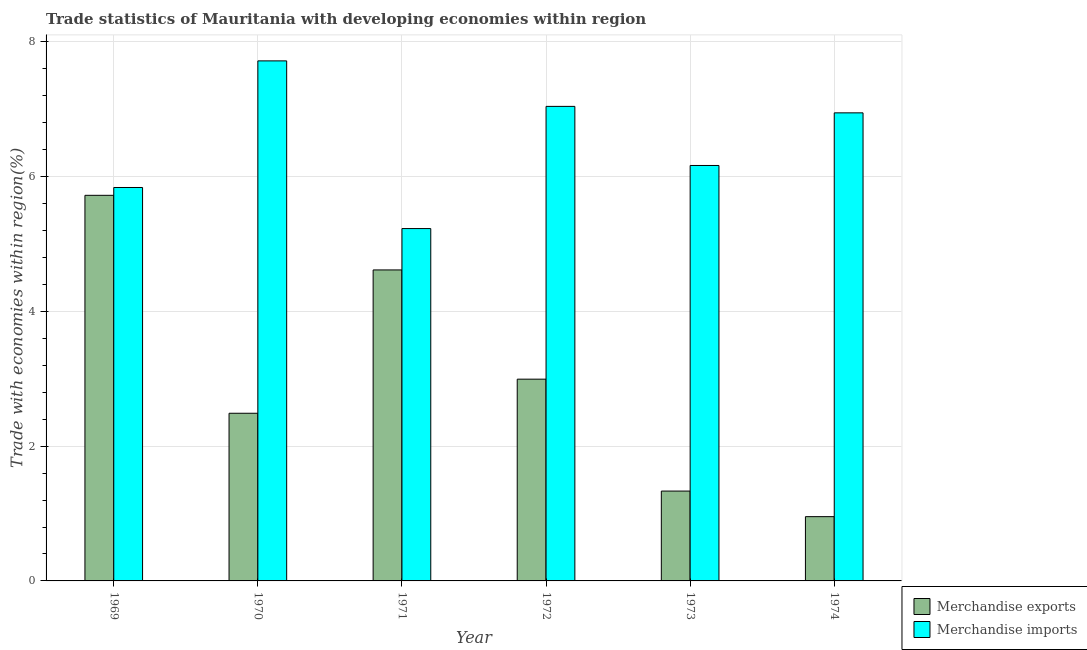How many different coloured bars are there?
Offer a terse response. 2. How many groups of bars are there?
Make the answer very short. 6. Are the number of bars per tick equal to the number of legend labels?
Your response must be concise. Yes. Are the number of bars on each tick of the X-axis equal?
Ensure brevity in your answer.  Yes. What is the label of the 1st group of bars from the left?
Your answer should be very brief. 1969. In how many cases, is the number of bars for a given year not equal to the number of legend labels?
Offer a terse response. 0. What is the merchandise exports in 1974?
Provide a succinct answer. 0.95. Across all years, what is the maximum merchandise exports?
Provide a succinct answer. 5.72. Across all years, what is the minimum merchandise imports?
Your answer should be very brief. 5.23. In which year was the merchandise exports maximum?
Your response must be concise. 1969. In which year was the merchandise exports minimum?
Make the answer very short. 1974. What is the total merchandise imports in the graph?
Make the answer very short. 38.93. What is the difference between the merchandise exports in 1971 and that in 1974?
Your answer should be compact. 3.66. What is the difference between the merchandise exports in 1969 and the merchandise imports in 1972?
Your response must be concise. 2.73. What is the average merchandise imports per year?
Offer a terse response. 6.49. In the year 1970, what is the difference between the merchandise exports and merchandise imports?
Your response must be concise. 0. What is the ratio of the merchandise exports in 1972 to that in 1974?
Make the answer very short. 3.14. Is the difference between the merchandise exports in 1969 and 1974 greater than the difference between the merchandise imports in 1969 and 1974?
Ensure brevity in your answer.  No. What is the difference between the highest and the second highest merchandise imports?
Keep it short and to the point. 0.68. What is the difference between the highest and the lowest merchandise imports?
Your response must be concise. 2.49. What does the 1st bar from the left in 1974 represents?
Provide a short and direct response. Merchandise exports. What does the 2nd bar from the right in 1973 represents?
Make the answer very short. Merchandise exports. How many bars are there?
Make the answer very short. 12. How many years are there in the graph?
Provide a short and direct response. 6. Are the values on the major ticks of Y-axis written in scientific E-notation?
Ensure brevity in your answer.  No. Does the graph contain any zero values?
Give a very brief answer. No. Does the graph contain grids?
Your answer should be very brief. Yes. Where does the legend appear in the graph?
Provide a short and direct response. Bottom right. How many legend labels are there?
Provide a short and direct response. 2. What is the title of the graph?
Provide a succinct answer. Trade statistics of Mauritania with developing economies within region. What is the label or title of the X-axis?
Keep it short and to the point. Year. What is the label or title of the Y-axis?
Give a very brief answer. Trade with economies within region(%). What is the Trade with economies within region(%) in Merchandise exports in 1969?
Offer a very short reply. 5.72. What is the Trade with economies within region(%) in Merchandise imports in 1969?
Offer a terse response. 5.84. What is the Trade with economies within region(%) of Merchandise exports in 1970?
Keep it short and to the point. 2.49. What is the Trade with economies within region(%) of Merchandise imports in 1970?
Provide a succinct answer. 7.72. What is the Trade with economies within region(%) in Merchandise exports in 1971?
Make the answer very short. 4.61. What is the Trade with economies within region(%) in Merchandise imports in 1971?
Give a very brief answer. 5.23. What is the Trade with economies within region(%) in Merchandise exports in 1972?
Give a very brief answer. 2.99. What is the Trade with economies within region(%) of Merchandise imports in 1972?
Your answer should be very brief. 7.04. What is the Trade with economies within region(%) of Merchandise exports in 1973?
Offer a terse response. 1.33. What is the Trade with economies within region(%) in Merchandise imports in 1973?
Offer a terse response. 6.16. What is the Trade with economies within region(%) in Merchandise exports in 1974?
Your answer should be very brief. 0.95. What is the Trade with economies within region(%) of Merchandise imports in 1974?
Give a very brief answer. 6.94. Across all years, what is the maximum Trade with economies within region(%) in Merchandise exports?
Make the answer very short. 5.72. Across all years, what is the maximum Trade with economies within region(%) in Merchandise imports?
Ensure brevity in your answer.  7.72. Across all years, what is the minimum Trade with economies within region(%) in Merchandise exports?
Make the answer very short. 0.95. Across all years, what is the minimum Trade with economies within region(%) in Merchandise imports?
Provide a succinct answer. 5.23. What is the total Trade with economies within region(%) of Merchandise exports in the graph?
Provide a short and direct response. 18.1. What is the total Trade with economies within region(%) in Merchandise imports in the graph?
Your answer should be compact. 38.93. What is the difference between the Trade with economies within region(%) of Merchandise exports in 1969 and that in 1970?
Give a very brief answer. 3.23. What is the difference between the Trade with economies within region(%) of Merchandise imports in 1969 and that in 1970?
Offer a very short reply. -1.88. What is the difference between the Trade with economies within region(%) in Merchandise exports in 1969 and that in 1971?
Your response must be concise. 1.11. What is the difference between the Trade with economies within region(%) of Merchandise imports in 1969 and that in 1971?
Your answer should be very brief. 0.61. What is the difference between the Trade with economies within region(%) of Merchandise exports in 1969 and that in 1972?
Your response must be concise. 2.73. What is the difference between the Trade with economies within region(%) in Merchandise imports in 1969 and that in 1972?
Provide a short and direct response. -1.2. What is the difference between the Trade with economies within region(%) of Merchandise exports in 1969 and that in 1973?
Your answer should be compact. 4.39. What is the difference between the Trade with economies within region(%) in Merchandise imports in 1969 and that in 1973?
Your answer should be compact. -0.33. What is the difference between the Trade with economies within region(%) in Merchandise exports in 1969 and that in 1974?
Give a very brief answer. 4.77. What is the difference between the Trade with economies within region(%) of Merchandise imports in 1969 and that in 1974?
Ensure brevity in your answer.  -1.11. What is the difference between the Trade with economies within region(%) in Merchandise exports in 1970 and that in 1971?
Keep it short and to the point. -2.13. What is the difference between the Trade with economies within region(%) in Merchandise imports in 1970 and that in 1971?
Your response must be concise. 2.49. What is the difference between the Trade with economies within region(%) of Merchandise exports in 1970 and that in 1972?
Your answer should be compact. -0.51. What is the difference between the Trade with economies within region(%) in Merchandise imports in 1970 and that in 1972?
Your answer should be compact. 0.68. What is the difference between the Trade with economies within region(%) in Merchandise exports in 1970 and that in 1973?
Your answer should be very brief. 1.15. What is the difference between the Trade with economies within region(%) in Merchandise imports in 1970 and that in 1973?
Keep it short and to the point. 1.55. What is the difference between the Trade with economies within region(%) in Merchandise exports in 1970 and that in 1974?
Provide a short and direct response. 1.53. What is the difference between the Trade with economies within region(%) of Merchandise imports in 1970 and that in 1974?
Your response must be concise. 0.77. What is the difference between the Trade with economies within region(%) in Merchandise exports in 1971 and that in 1972?
Your response must be concise. 1.62. What is the difference between the Trade with economies within region(%) in Merchandise imports in 1971 and that in 1972?
Ensure brevity in your answer.  -1.81. What is the difference between the Trade with economies within region(%) of Merchandise exports in 1971 and that in 1973?
Your response must be concise. 3.28. What is the difference between the Trade with economies within region(%) of Merchandise imports in 1971 and that in 1973?
Your response must be concise. -0.94. What is the difference between the Trade with economies within region(%) in Merchandise exports in 1971 and that in 1974?
Keep it short and to the point. 3.66. What is the difference between the Trade with economies within region(%) of Merchandise imports in 1971 and that in 1974?
Offer a terse response. -1.72. What is the difference between the Trade with economies within region(%) in Merchandise exports in 1972 and that in 1973?
Make the answer very short. 1.66. What is the difference between the Trade with economies within region(%) in Merchandise imports in 1972 and that in 1973?
Provide a short and direct response. 0.88. What is the difference between the Trade with economies within region(%) in Merchandise exports in 1972 and that in 1974?
Give a very brief answer. 2.04. What is the difference between the Trade with economies within region(%) in Merchandise imports in 1972 and that in 1974?
Ensure brevity in your answer.  0.1. What is the difference between the Trade with economies within region(%) of Merchandise exports in 1973 and that in 1974?
Make the answer very short. 0.38. What is the difference between the Trade with economies within region(%) in Merchandise imports in 1973 and that in 1974?
Your answer should be very brief. -0.78. What is the difference between the Trade with economies within region(%) in Merchandise exports in 1969 and the Trade with economies within region(%) in Merchandise imports in 1970?
Offer a terse response. -1.99. What is the difference between the Trade with economies within region(%) of Merchandise exports in 1969 and the Trade with economies within region(%) of Merchandise imports in 1971?
Your answer should be compact. 0.49. What is the difference between the Trade with economies within region(%) of Merchandise exports in 1969 and the Trade with economies within region(%) of Merchandise imports in 1972?
Ensure brevity in your answer.  -1.32. What is the difference between the Trade with economies within region(%) in Merchandise exports in 1969 and the Trade with economies within region(%) in Merchandise imports in 1973?
Make the answer very short. -0.44. What is the difference between the Trade with economies within region(%) in Merchandise exports in 1969 and the Trade with economies within region(%) in Merchandise imports in 1974?
Your answer should be compact. -1.22. What is the difference between the Trade with economies within region(%) of Merchandise exports in 1970 and the Trade with economies within region(%) of Merchandise imports in 1971?
Your answer should be compact. -2.74. What is the difference between the Trade with economies within region(%) in Merchandise exports in 1970 and the Trade with economies within region(%) in Merchandise imports in 1972?
Make the answer very short. -4.55. What is the difference between the Trade with economies within region(%) of Merchandise exports in 1970 and the Trade with economies within region(%) of Merchandise imports in 1973?
Your response must be concise. -3.68. What is the difference between the Trade with economies within region(%) of Merchandise exports in 1970 and the Trade with economies within region(%) of Merchandise imports in 1974?
Your answer should be very brief. -4.46. What is the difference between the Trade with economies within region(%) of Merchandise exports in 1971 and the Trade with economies within region(%) of Merchandise imports in 1972?
Provide a short and direct response. -2.43. What is the difference between the Trade with economies within region(%) of Merchandise exports in 1971 and the Trade with economies within region(%) of Merchandise imports in 1973?
Provide a succinct answer. -1.55. What is the difference between the Trade with economies within region(%) of Merchandise exports in 1971 and the Trade with economies within region(%) of Merchandise imports in 1974?
Provide a short and direct response. -2.33. What is the difference between the Trade with economies within region(%) in Merchandise exports in 1972 and the Trade with economies within region(%) in Merchandise imports in 1973?
Give a very brief answer. -3.17. What is the difference between the Trade with economies within region(%) of Merchandise exports in 1972 and the Trade with economies within region(%) of Merchandise imports in 1974?
Make the answer very short. -3.95. What is the difference between the Trade with economies within region(%) of Merchandise exports in 1973 and the Trade with economies within region(%) of Merchandise imports in 1974?
Give a very brief answer. -5.61. What is the average Trade with economies within region(%) in Merchandise exports per year?
Ensure brevity in your answer.  3.02. What is the average Trade with economies within region(%) of Merchandise imports per year?
Your response must be concise. 6.49. In the year 1969, what is the difference between the Trade with economies within region(%) of Merchandise exports and Trade with economies within region(%) of Merchandise imports?
Give a very brief answer. -0.12. In the year 1970, what is the difference between the Trade with economies within region(%) of Merchandise exports and Trade with economies within region(%) of Merchandise imports?
Provide a succinct answer. -5.23. In the year 1971, what is the difference between the Trade with economies within region(%) in Merchandise exports and Trade with economies within region(%) in Merchandise imports?
Give a very brief answer. -0.61. In the year 1972, what is the difference between the Trade with economies within region(%) in Merchandise exports and Trade with economies within region(%) in Merchandise imports?
Offer a very short reply. -4.05. In the year 1973, what is the difference between the Trade with economies within region(%) of Merchandise exports and Trade with economies within region(%) of Merchandise imports?
Offer a terse response. -4.83. In the year 1974, what is the difference between the Trade with economies within region(%) of Merchandise exports and Trade with economies within region(%) of Merchandise imports?
Your answer should be compact. -5.99. What is the ratio of the Trade with economies within region(%) of Merchandise exports in 1969 to that in 1970?
Your response must be concise. 2.3. What is the ratio of the Trade with economies within region(%) in Merchandise imports in 1969 to that in 1970?
Keep it short and to the point. 0.76. What is the ratio of the Trade with economies within region(%) in Merchandise exports in 1969 to that in 1971?
Give a very brief answer. 1.24. What is the ratio of the Trade with economies within region(%) of Merchandise imports in 1969 to that in 1971?
Make the answer very short. 1.12. What is the ratio of the Trade with economies within region(%) of Merchandise exports in 1969 to that in 1972?
Provide a short and direct response. 1.91. What is the ratio of the Trade with economies within region(%) in Merchandise imports in 1969 to that in 1972?
Your answer should be compact. 0.83. What is the ratio of the Trade with economies within region(%) in Merchandise exports in 1969 to that in 1973?
Your answer should be very brief. 4.29. What is the ratio of the Trade with economies within region(%) in Merchandise imports in 1969 to that in 1973?
Offer a terse response. 0.95. What is the ratio of the Trade with economies within region(%) of Merchandise exports in 1969 to that in 1974?
Offer a terse response. 6. What is the ratio of the Trade with economies within region(%) in Merchandise imports in 1969 to that in 1974?
Your answer should be very brief. 0.84. What is the ratio of the Trade with economies within region(%) of Merchandise exports in 1970 to that in 1971?
Give a very brief answer. 0.54. What is the ratio of the Trade with economies within region(%) in Merchandise imports in 1970 to that in 1971?
Ensure brevity in your answer.  1.48. What is the ratio of the Trade with economies within region(%) of Merchandise exports in 1970 to that in 1972?
Give a very brief answer. 0.83. What is the ratio of the Trade with economies within region(%) in Merchandise imports in 1970 to that in 1972?
Offer a terse response. 1.1. What is the ratio of the Trade with economies within region(%) of Merchandise exports in 1970 to that in 1973?
Provide a succinct answer. 1.87. What is the ratio of the Trade with economies within region(%) of Merchandise imports in 1970 to that in 1973?
Offer a terse response. 1.25. What is the ratio of the Trade with economies within region(%) of Merchandise exports in 1970 to that in 1974?
Ensure brevity in your answer.  2.61. What is the ratio of the Trade with economies within region(%) of Merchandise imports in 1970 to that in 1974?
Ensure brevity in your answer.  1.11. What is the ratio of the Trade with economies within region(%) of Merchandise exports in 1971 to that in 1972?
Provide a short and direct response. 1.54. What is the ratio of the Trade with economies within region(%) of Merchandise imports in 1971 to that in 1972?
Your answer should be compact. 0.74. What is the ratio of the Trade with economies within region(%) in Merchandise exports in 1971 to that in 1973?
Your response must be concise. 3.46. What is the ratio of the Trade with economies within region(%) in Merchandise imports in 1971 to that in 1973?
Keep it short and to the point. 0.85. What is the ratio of the Trade with economies within region(%) in Merchandise exports in 1971 to that in 1974?
Give a very brief answer. 4.84. What is the ratio of the Trade with economies within region(%) in Merchandise imports in 1971 to that in 1974?
Offer a terse response. 0.75. What is the ratio of the Trade with economies within region(%) of Merchandise exports in 1972 to that in 1973?
Your answer should be compact. 2.25. What is the ratio of the Trade with economies within region(%) in Merchandise imports in 1972 to that in 1973?
Provide a succinct answer. 1.14. What is the ratio of the Trade with economies within region(%) of Merchandise exports in 1972 to that in 1974?
Offer a terse response. 3.14. What is the ratio of the Trade with economies within region(%) of Merchandise imports in 1972 to that in 1974?
Provide a short and direct response. 1.01. What is the ratio of the Trade with economies within region(%) of Merchandise exports in 1973 to that in 1974?
Your answer should be compact. 1.4. What is the ratio of the Trade with economies within region(%) in Merchandise imports in 1973 to that in 1974?
Keep it short and to the point. 0.89. What is the difference between the highest and the second highest Trade with economies within region(%) of Merchandise exports?
Make the answer very short. 1.11. What is the difference between the highest and the second highest Trade with economies within region(%) in Merchandise imports?
Make the answer very short. 0.68. What is the difference between the highest and the lowest Trade with economies within region(%) of Merchandise exports?
Your response must be concise. 4.77. What is the difference between the highest and the lowest Trade with economies within region(%) in Merchandise imports?
Keep it short and to the point. 2.49. 